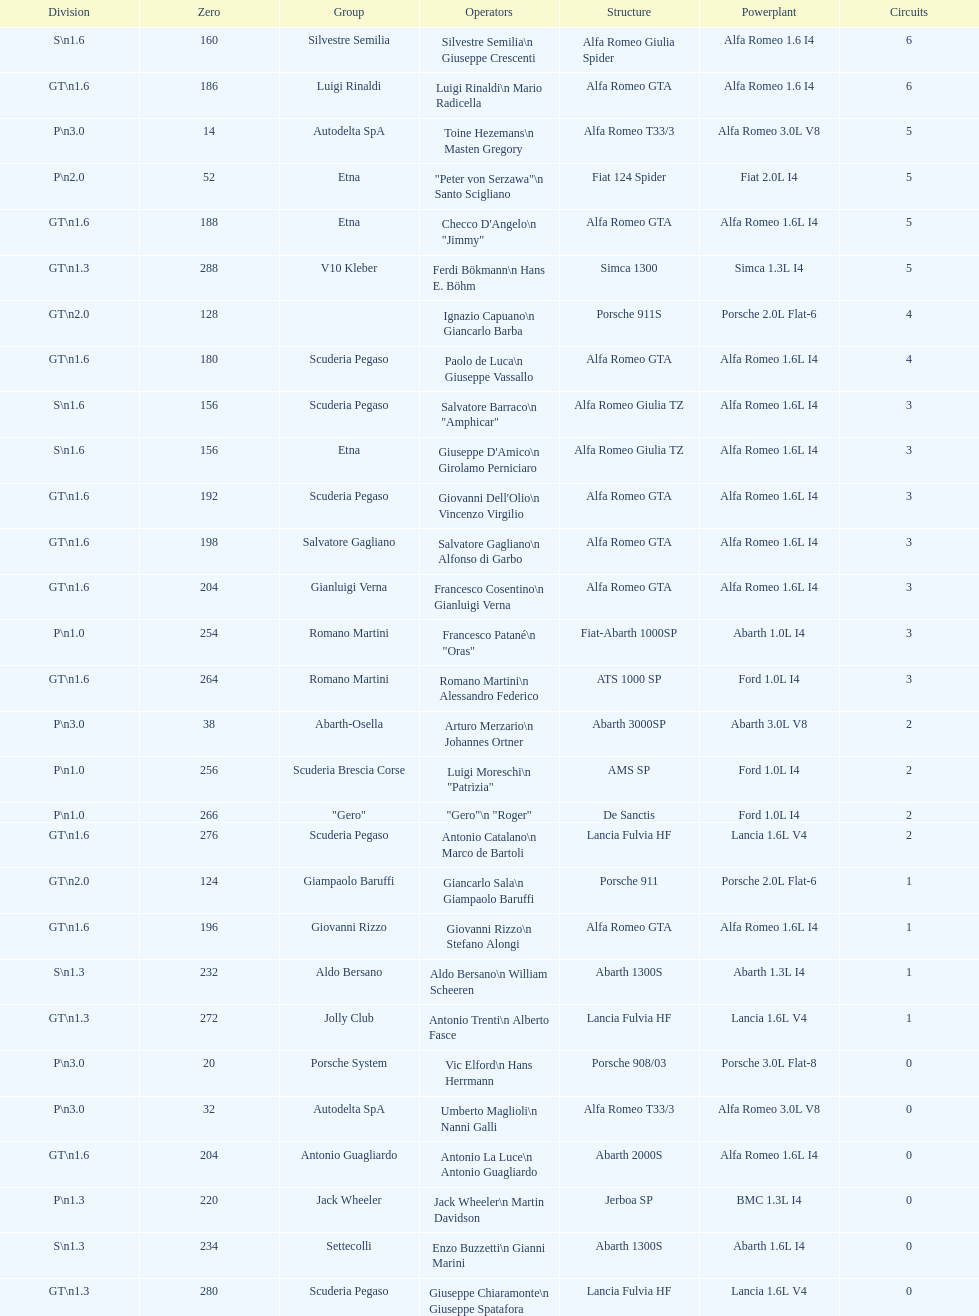What class is below s 1.6? GT 1.6. 